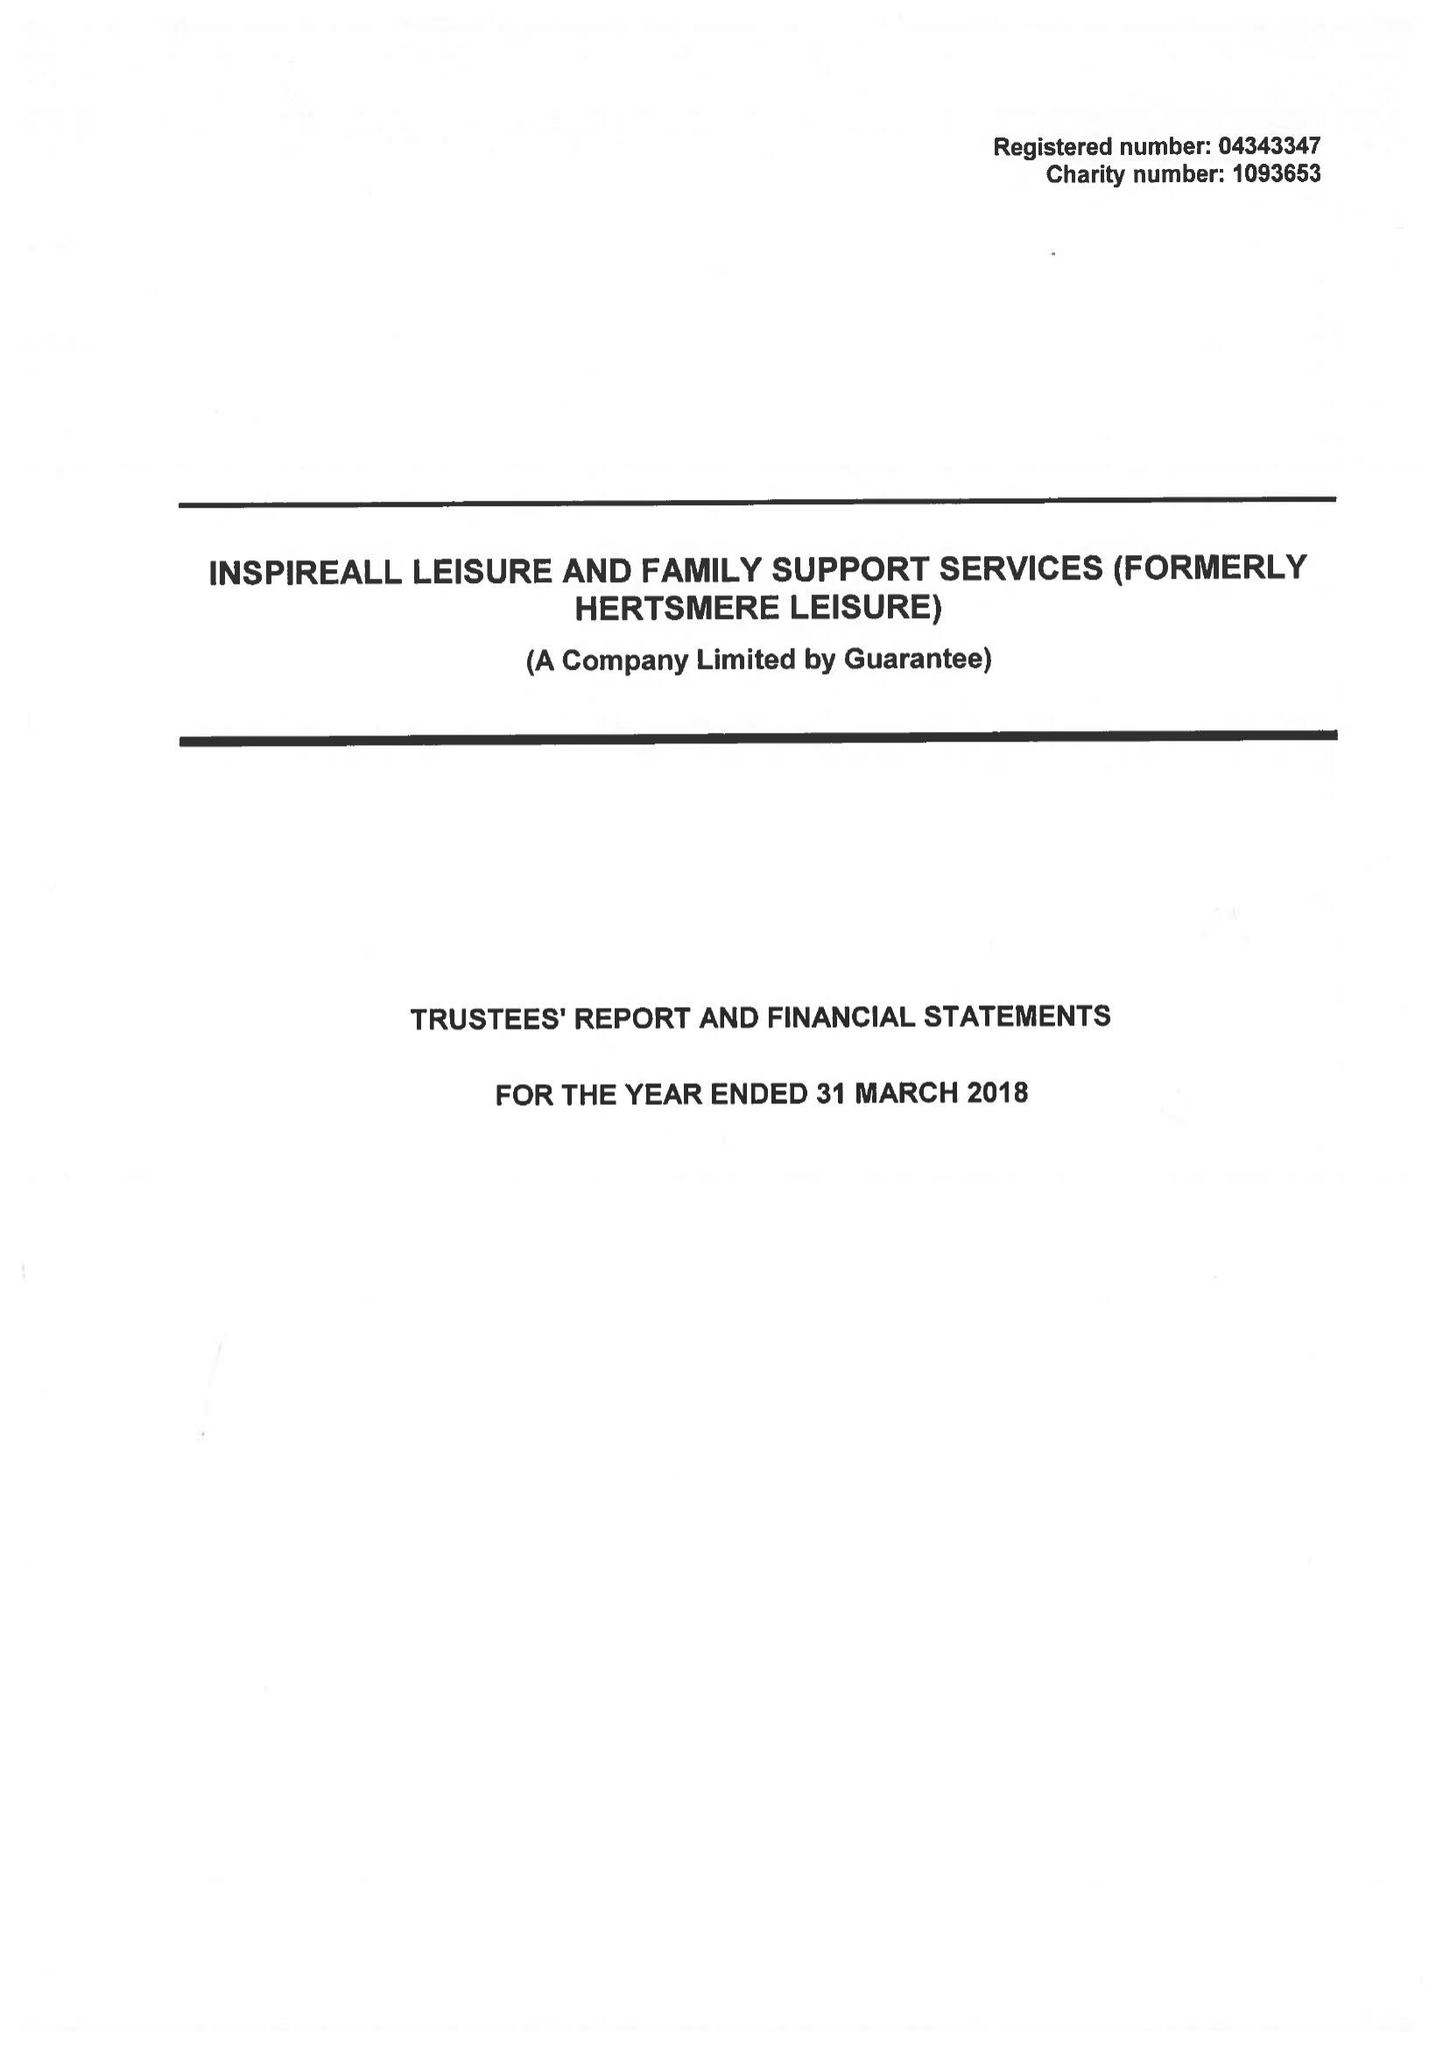What is the value for the charity_number?
Answer the question using a single word or phrase. 1093653 